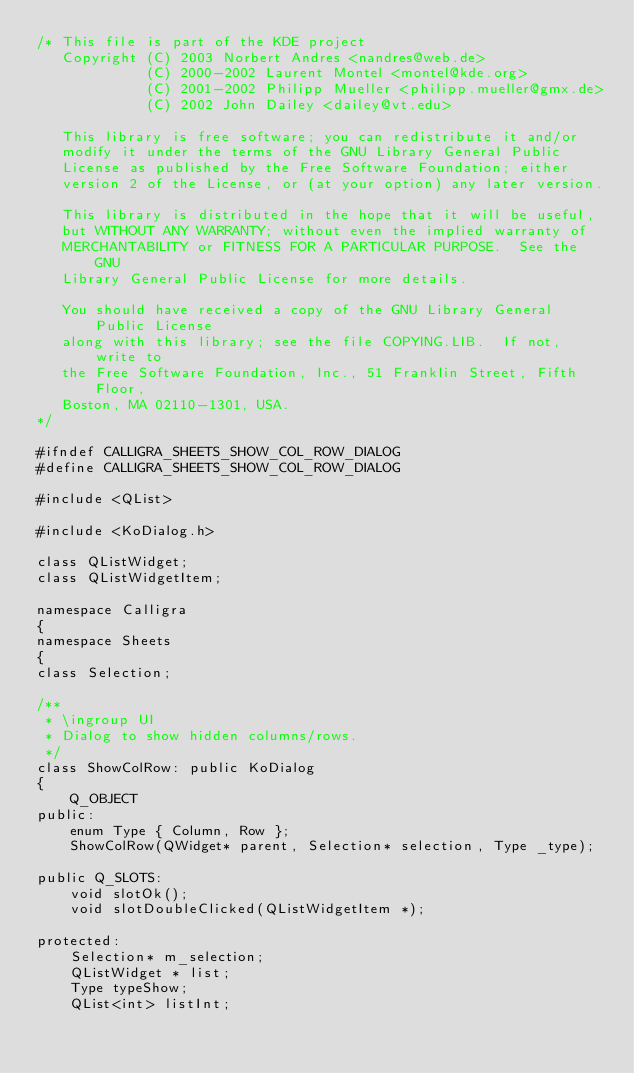Convert code to text. <code><loc_0><loc_0><loc_500><loc_500><_C_>/* This file is part of the KDE project
   Copyright (C) 2003 Norbert Andres <nandres@web.de>
             (C) 2000-2002 Laurent Montel <montel@kde.org>
             (C) 2001-2002 Philipp Mueller <philipp.mueller@gmx.de>
             (C) 2002 John Dailey <dailey@vt.edu>

   This library is free software; you can redistribute it and/or
   modify it under the terms of the GNU Library General Public
   License as published by the Free Software Foundation; either
   version 2 of the License, or (at your option) any later version.

   This library is distributed in the hope that it will be useful,
   but WITHOUT ANY WARRANTY; without even the implied warranty of
   MERCHANTABILITY or FITNESS FOR A PARTICULAR PURPOSE.  See the GNU
   Library General Public License for more details.

   You should have received a copy of the GNU Library General Public License
   along with this library; see the file COPYING.LIB.  If not, write to
   the Free Software Foundation, Inc., 51 Franklin Street, Fifth Floor,
   Boston, MA 02110-1301, USA.
*/

#ifndef CALLIGRA_SHEETS_SHOW_COL_ROW_DIALOG
#define CALLIGRA_SHEETS_SHOW_COL_ROW_DIALOG

#include <QList>

#include <KoDialog.h>

class QListWidget;
class QListWidgetItem;

namespace Calligra
{
namespace Sheets
{
class Selection;

/**
 * \ingroup UI
 * Dialog to show hidden columns/rows.
 */
class ShowColRow: public KoDialog
{
    Q_OBJECT
public:
    enum Type { Column, Row };
    ShowColRow(QWidget* parent, Selection* selection, Type _type);

public Q_SLOTS:
    void slotOk();
    void slotDoubleClicked(QListWidgetItem *);

protected:
    Selection* m_selection;
    QListWidget * list;
    Type typeShow;
    QList<int> listInt;</code> 